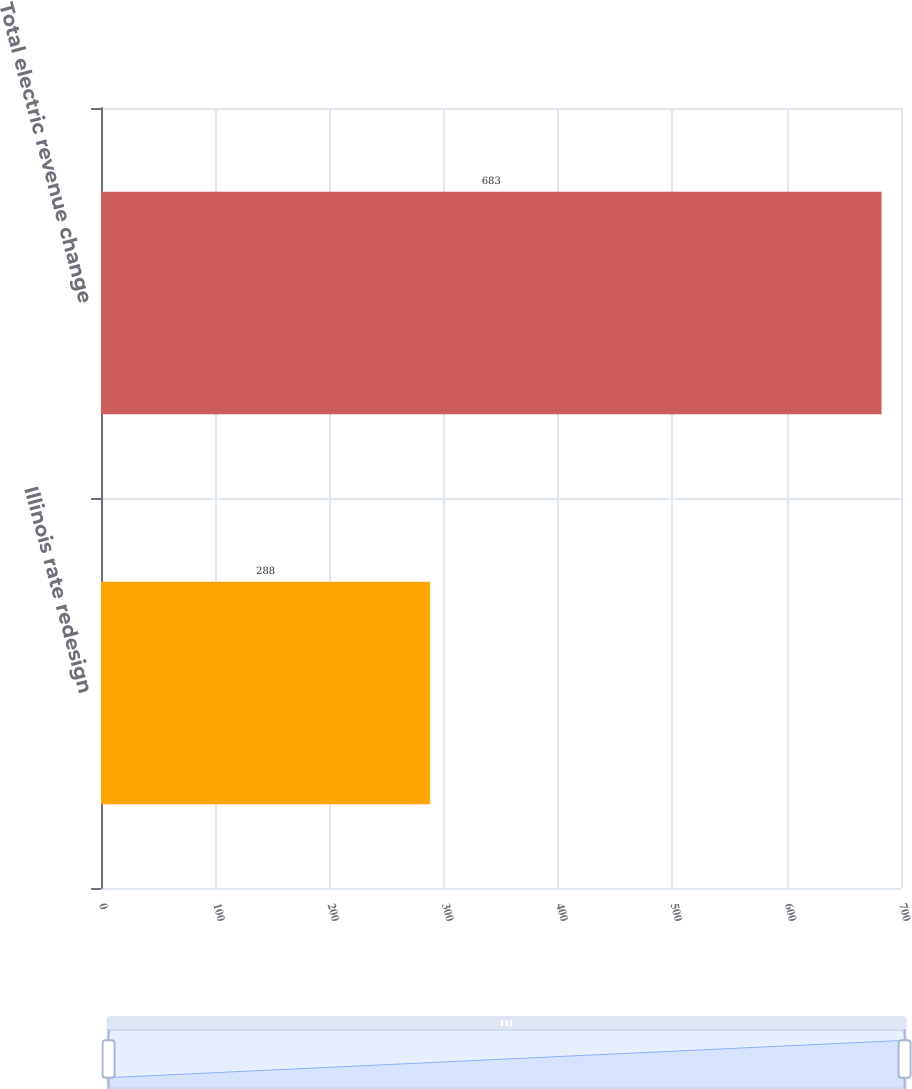Convert chart to OTSL. <chart><loc_0><loc_0><loc_500><loc_500><bar_chart><fcel>Illinois rate redesign<fcel>Total electric revenue change<nl><fcel>288<fcel>683<nl></chart> 